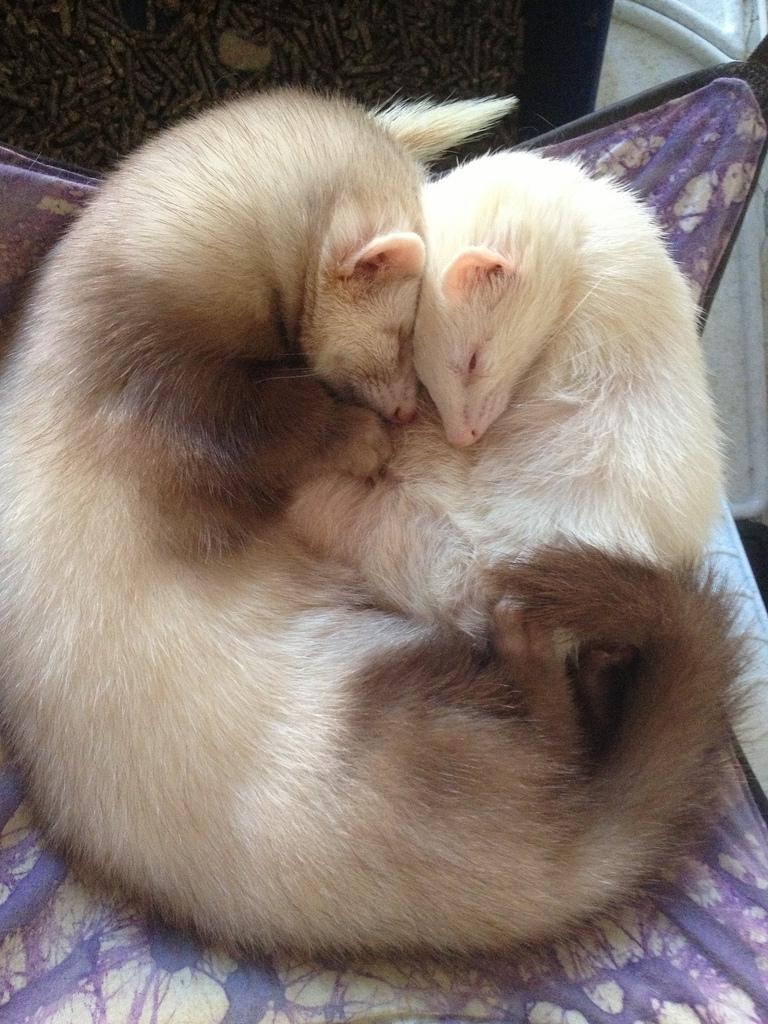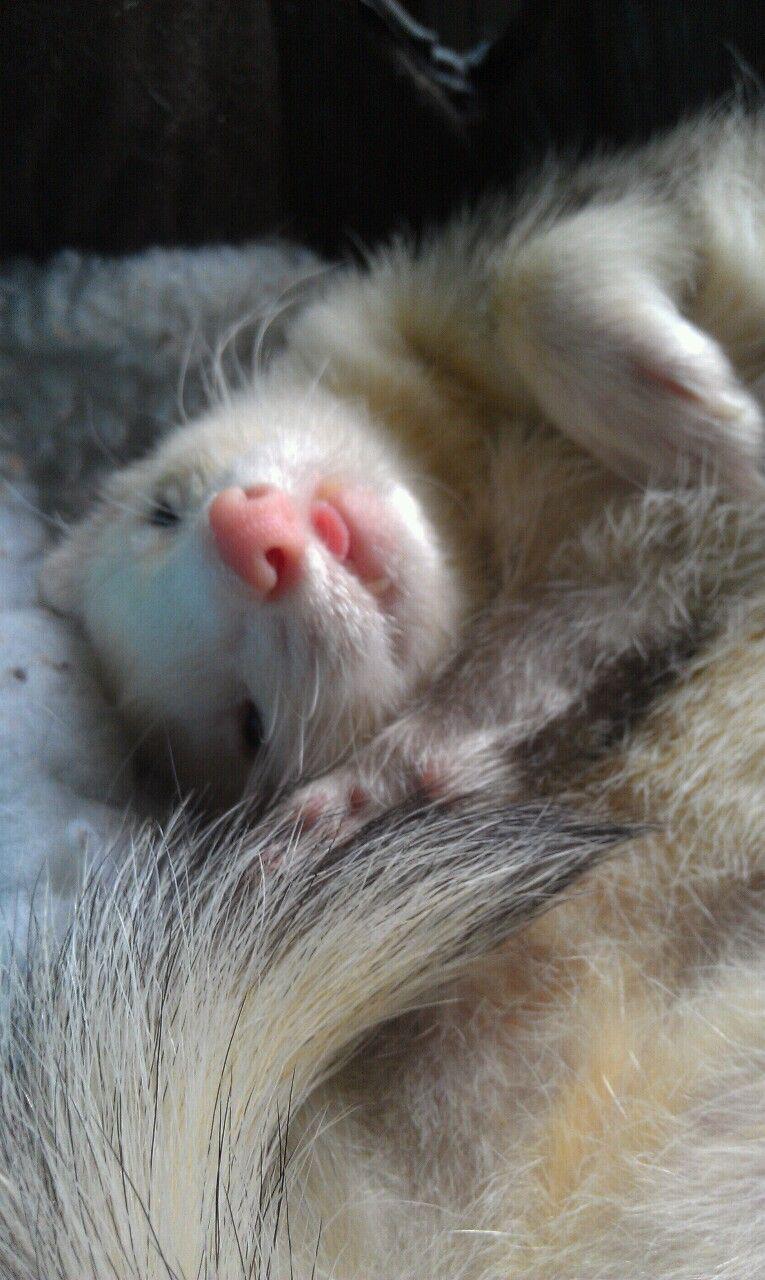The first image is the image on the left, the second image is the image on the right. Analyze the images presented: Is the assertion "In one image there is a lone ferret sleeping with its tongue sticking out." valid? Answer yes or no. Yes. The first image is the image on the left, the second image is the image on the right. Examine the images to the left and right. Is the description "There are exactly three ferrets in total." accurate? Answer yes or no. Yes. 